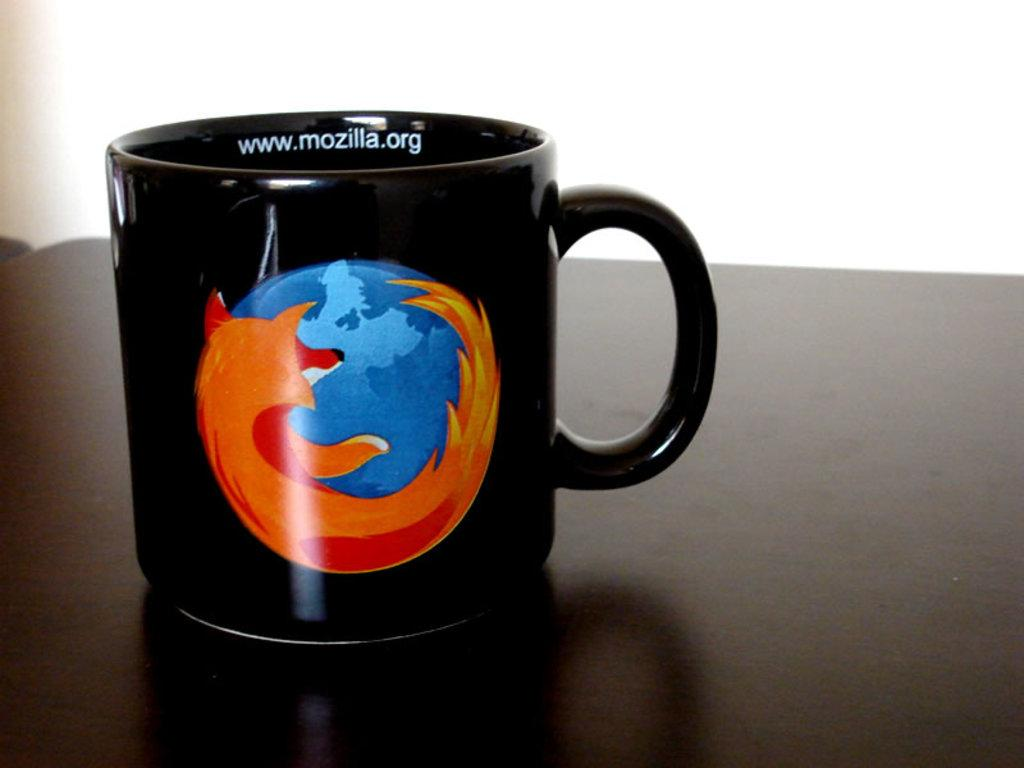What object is present in the image? There is a cup in the image. Where is the cup located? The cup is on a surface. What design element is present on the front view of the cup? The cup has a logo on the front view. What can be seen on the inner view of the cup? The cup has text on the inner view. How many horses are visible in the image? There are no horses present in the image; it features a cup with a logo and text. What type of animal can be seen interacting with the cup in the image? There is no animal interacting with the cup in the image; only the cup and its design elements are present. 